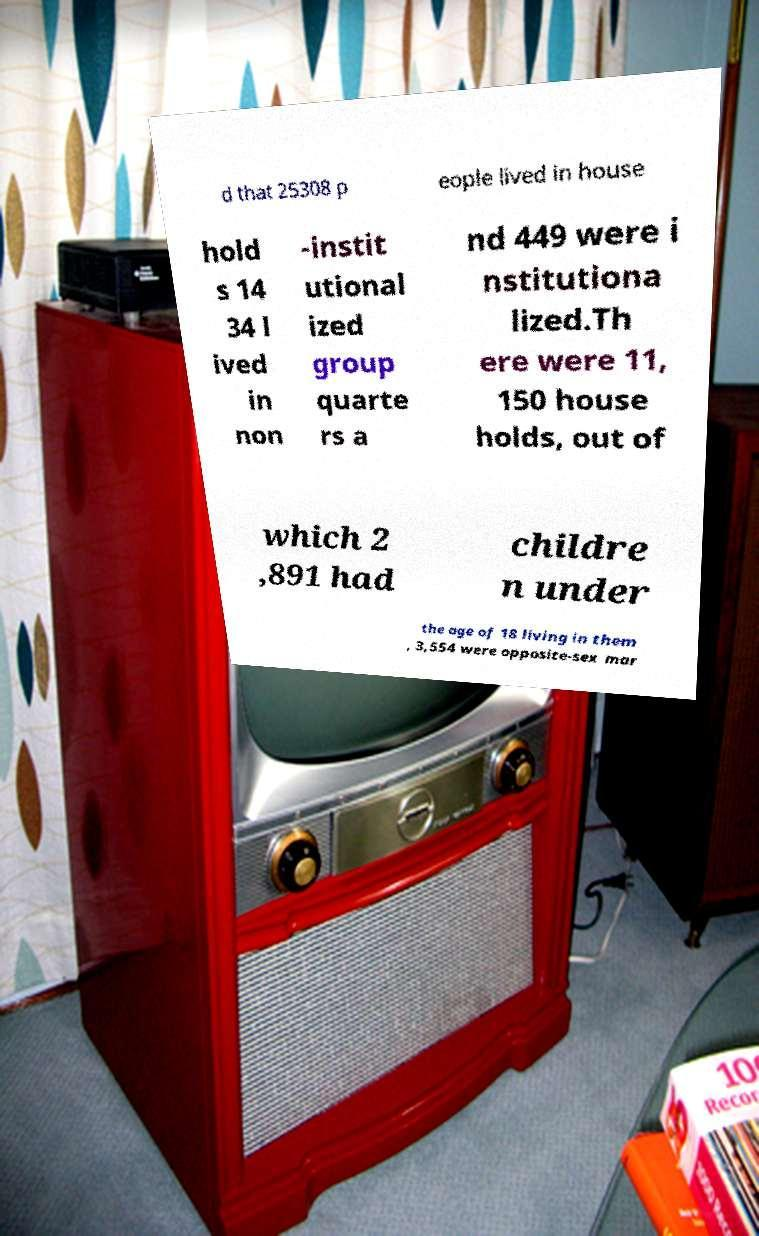Please identify and transcribe the text found in this image. d that 25308 p eople lived in house hold s 14 34 l ived in non -instit utional ized group quarte rs a nd 449 were i nstitutiona lized.Th ere were 11, 150 house holds, out of which 2 ,891 had childre n under the age of 18 living in them , 3,554 were opposite-sex mar 